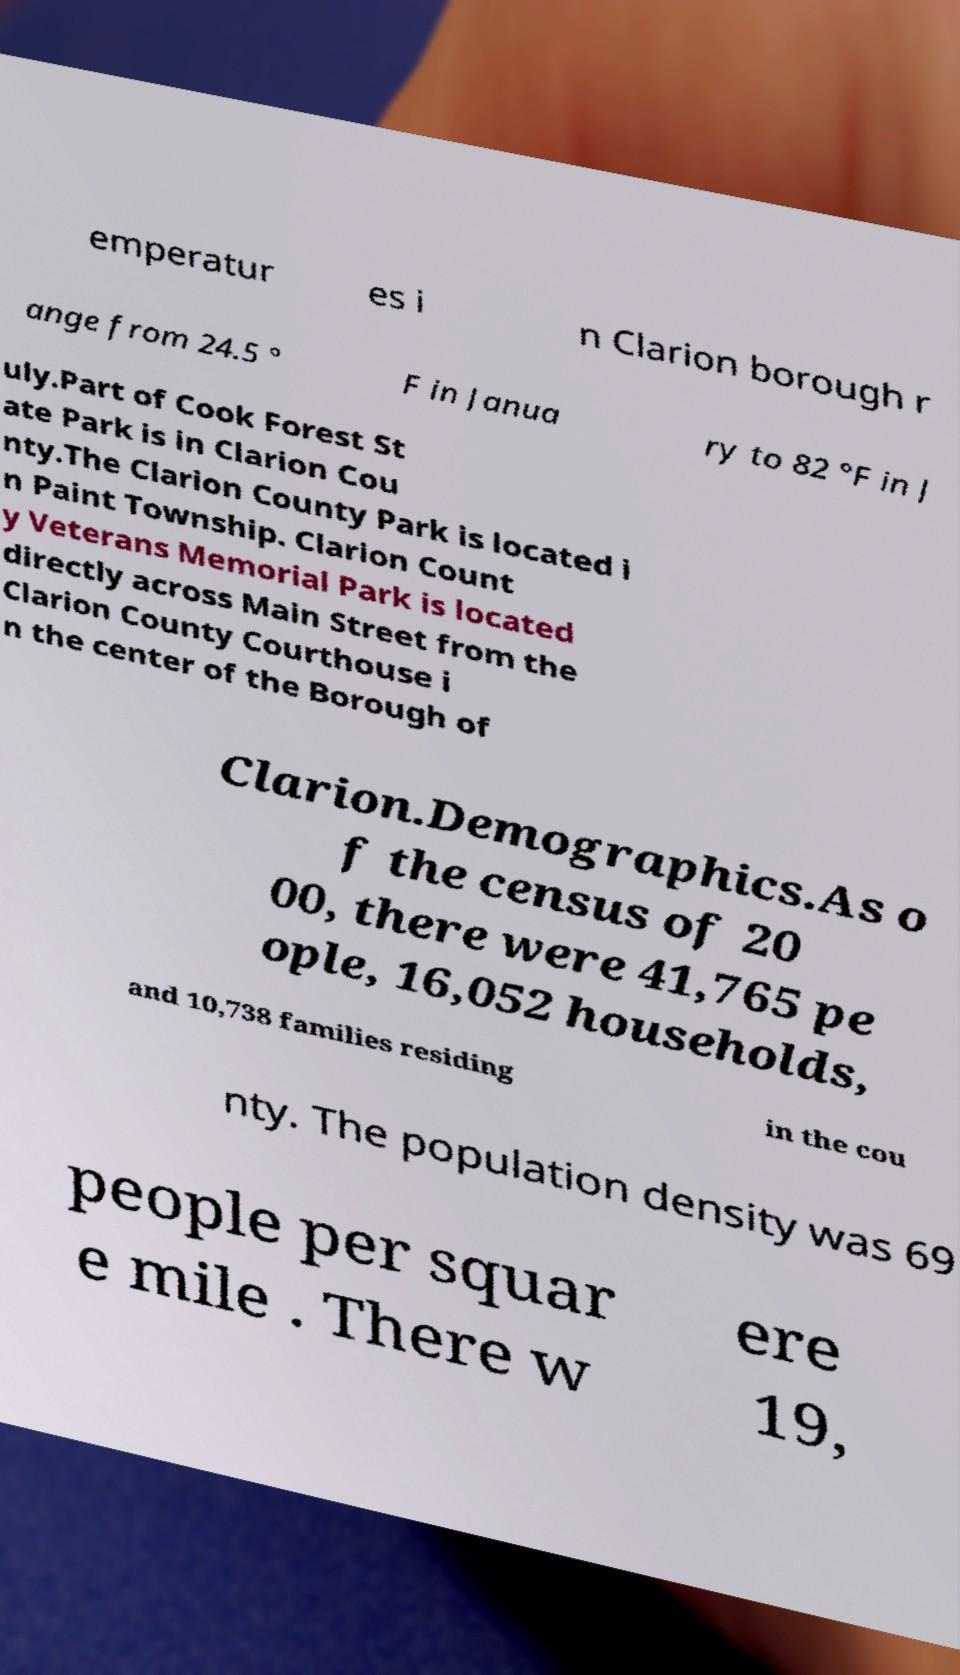Please read and relay the text visible in this image. What does it say? emperatur es i n Clarion borough r ange from 24.5 ° F in Janua ry to 82 °F in J uly.Part of Cook Forest St ate Park is in Clarion Cou nty.The Clarion County Park is located i n Paint Township. Clarion Count y Veterans Memorial Park is located directly across Main Street from the Clarion County Courthouse i n the center of the Borough of Clarion.Demographics.As o f the census of 20 00, there were 41,765 pe ople, 16,052 households, and 10,738 families residing in the cou nty. The population density was 69 people per squar e mile . There w ere 19, 